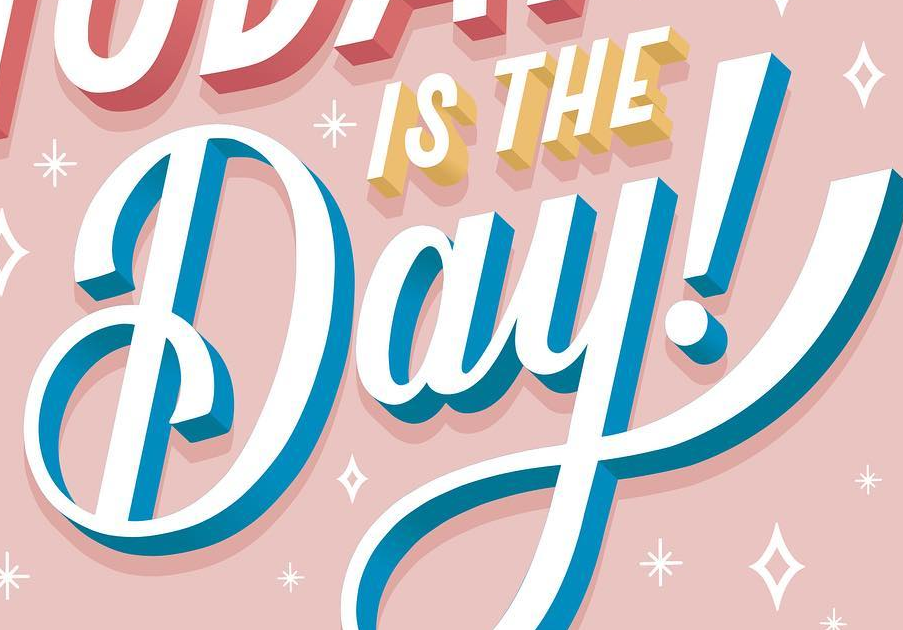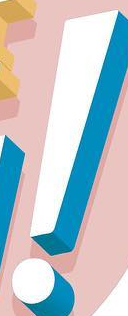Read the text from these images in sequence, separated by a semicolon. Day; ! 